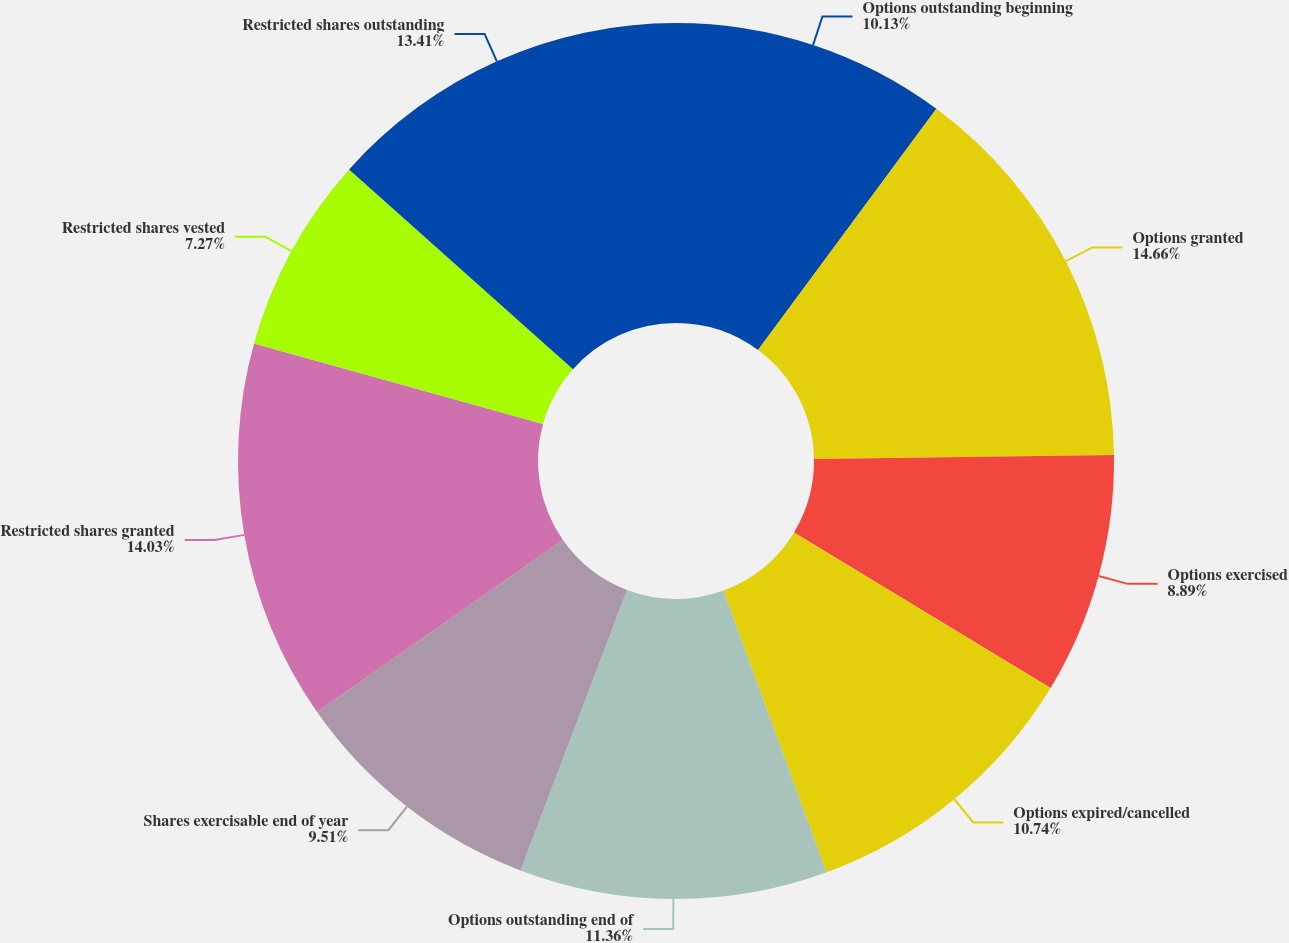Convert chart. <chart><loc_0><loc_0><loc_500><loc_500><pie_chart><fcel>Options outstanding beginning<fcel>Options granted<fcel>Options exercised<fcel>Options expired/cancelled<fcel>Options outstanding end of<fcel>Shares exercisable end of year<fcel>Restricted shares granted<fcel>Restricted shares vested<fcel>Restricted shares outstanding<nl><fcel>10.13%<fcel>14.65%<fcel>8.89%<fcel>10.74%<fcel>11.36%<fcel>9.51%<fcel>14.03%<fcel>7.27%<fcel>13.41%<nl></chart> 